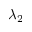Convert formula to latex. <formula><loc_0><loc_0><loc_500><loc_500>\lambda _ { 2 }</formula> 